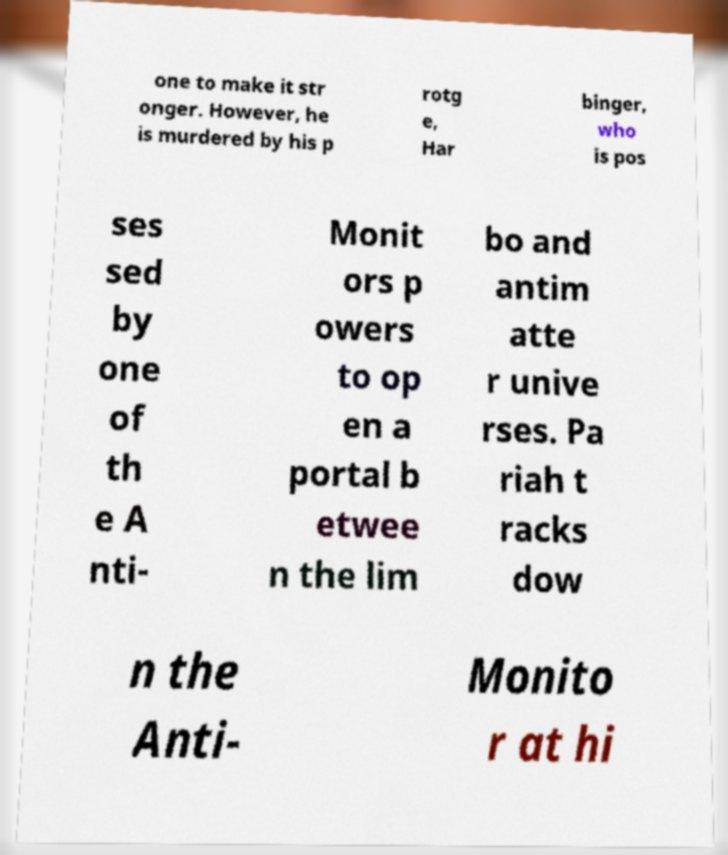I need the written content from this picture converted into text. Can you do that? one to make it str onger. However, he is murdered by his p rotg e, Har binger, who is pos ses sed by one of th e A nti- Monit ors p owers to op en a portal b etwee n the lim bo and antim atte r unive rses. Pa riah t racks dow n the Anti- Monito r at hi 